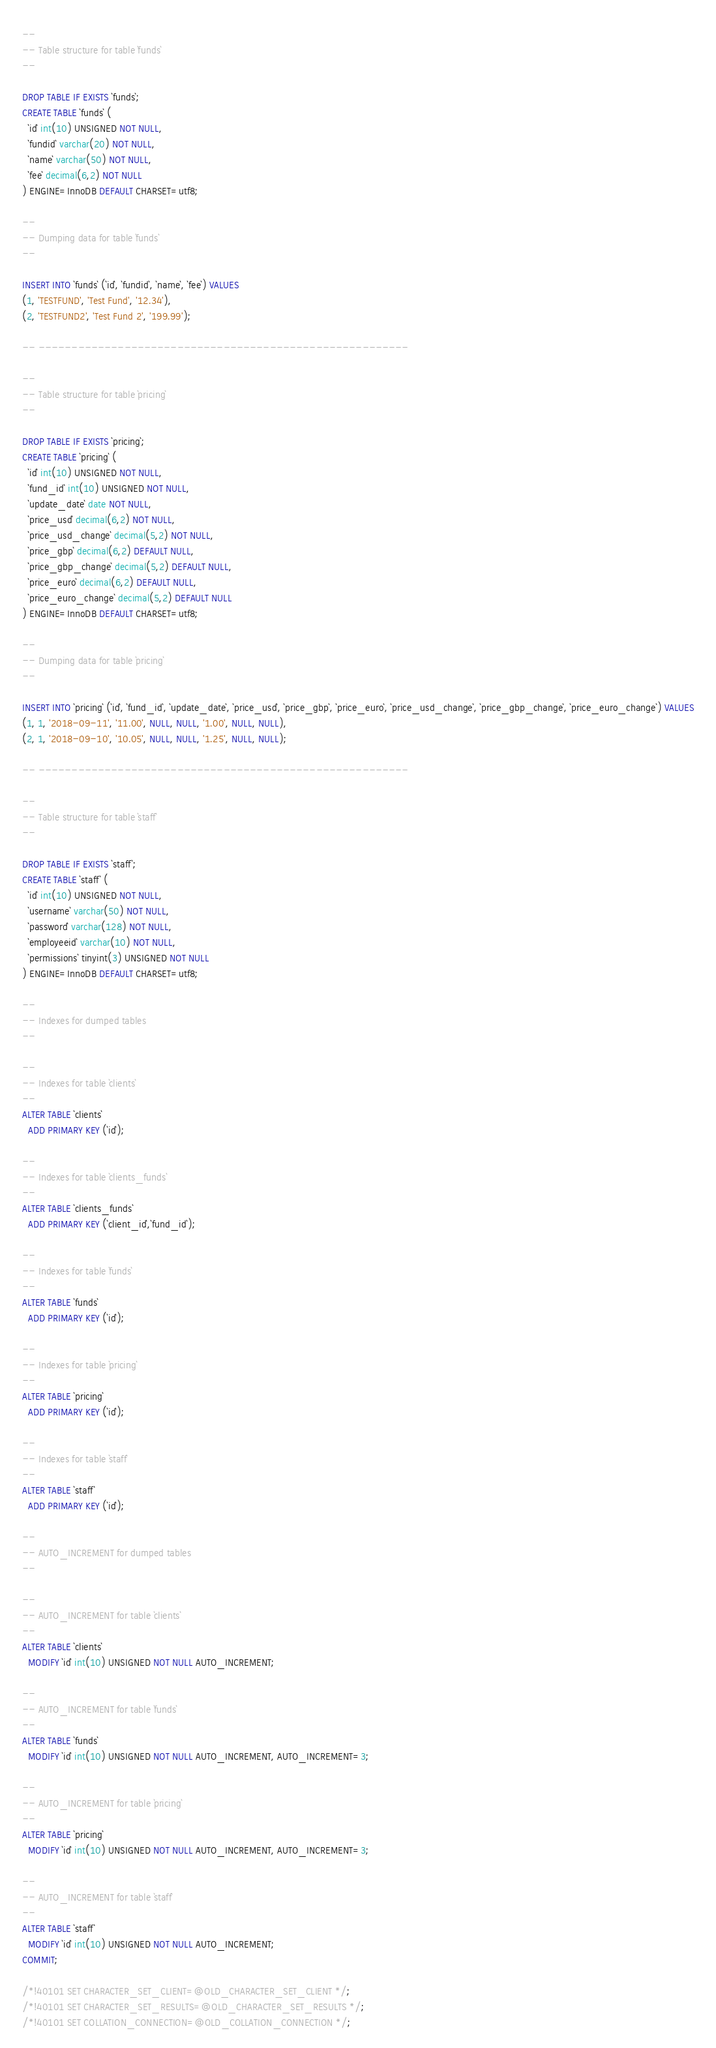Convert code to text. <code><loc_0><loc_0><loc_500><loc_500><_SQL_>--
-- Table structure for table `funds`
--

DROP TABLE IF EXISTS `funds`;
CREATE TABLE `funds` (
  `id` int(10) UNSIGNED NOT NULL,
  `fundid` varchar(20) NOT NULL,
  `name` varchar(50) NOT NULL,
  `fee` decimal(6,2) NOT NULL
) ENGINE=InnoDB DEFAULT CHARSET=utf8;

--
-- Dumping data for table `funds`
--

INSERT INTO `funds` (`id`, `fundid`, `name`, `fee`) VALUES
(1, 'TESTFUND', 'Test Fund', '12.34'),
(2, 'TESTFUND2', 'Test Fund 2', '199.99');

-- --------------------------------------------------------

--
-- Table structure for table `pricing`
--

DROP TABLE IF EXISTS `pricing`;
CREATE TABLE `pricing` (
  `id` int(10) UNSIGNED NOT NULL,
  `fund_id` int(10) UNSIGNED NOT NULL,
  `update_date` date NOT NULL,
  `price_usd` decimal(6,2) NOT NULL,
  `price_usd_change` decimal(5,2) NOT NULL,
  `price_gbp` decimal(6,2) DEFAULT NULL,
  `price_gbp_change` decimal(5,2) DEFAULT NULL,
  `price_euro` decimal(6,2) DEFAULT NULL,
  `price_euro_change` decimal(5,2) DEFAULT NULL
) ENGINE=InnoDB DEFAULT CHARSET=utf8;

--
-- Dumping data for table `pricing`
--

INSERT INTO `pricing` (`id`, `fund_id`, `update_date`, `price_usd`, `price_gbp`, `price_euro`, `price_usd_change`, `price_gbp_change`, `price_euro_change`) VALUES
(1, 1, '2018-09-11', '11.00', NULL, NULL, '1.00', NULL, NULL),
(2, 1, '2018-09-10', '10.05', NULL, NULL, '1.25', NULL, NULL);

-- --------------------------------------------------------

--
-- Table structure for table `staff`
--

DROP TABLE IF EXISTS `staff`;
CREATE TABLE `staff` (
  `id` int(10) UNSIGNED NOT NULL,
  `username` varchar(50) NOT NULL,
  `password` varchar(128) NOT NULL,
  `employeeid` varchar(10) NOT NULL,
  `permissions` tinyint(3) UNSIGNED NOT NULL
) ENGINE=InnoDB DEFAULT CHARSET=utf8;

--
-- Indexes for dumped tables
--

--
-- Indexes for table `clients`
--
ALTER TABLE `clients`
  ADD PRIMARY KEY (`id`);

--
-- Indexes for table `clients_funds`
--
ALTER TABLE `clients_funds`
  ADD PRIMARY KEY (`client_id`,`fund_id`);

--
-- Indexes for table `funds`
--
ALTER TABLE `funds`
  ADD PRIMARY KEY (`id`);

--
-- Indexes for table `pricing`
--
ALTER TABLE `pricing`
  ADD PRIMARY KEY (`id`);

--
-- Indexes for table `staff`
--
ALTER TABLE `staff`
  ADD PRIMARY KEY (`id`);

--
-- AUTO_INCREMENT for dumped tables
--

--
-- AUTO_INCREMENT for table `clients`
--
ALTER TABLE `clients`
  MODIFY `id` int(10) UNSIGNED NOT NULL AUTO_INCREMENT;

--
-- AUTO_INCREMENT for table `funds`
--
ALTER TABLE `funds`
  MODIFY `id` int(10) UNSIGNED NOT NULL AUTO_INCREMENT, AUTO_INCREMENT=3;

--
-- AUTO_INCREMENT for table `pricing`
--
ALTER TABLE `pricing`
  MODIFY `id` int(10) UNSIGNED NOT NULL AUTO_INCREMENT, AUTO_INCREMENT=3;

--
-- AUTO_INCREMENT for table `staff`
--
ALTER TABLE `staff`
  MODIFY `id` int(10) UNSIGNED NOT NULL AUTO_INCREMENT;
COMMIT;

/*!40101 SET CHARACTER_SET_CLIENT=@OLD_CHARACTER_SET_CLIENT */;
/*!40101 SET CHARACTER_SET_RESULTS=@OLD_CHARACTER_SET_RESULTS */;
/*!40101 SET COLLATION_CONNECTION=@OLD_COLLATION_CONNECTION */;
</code> 